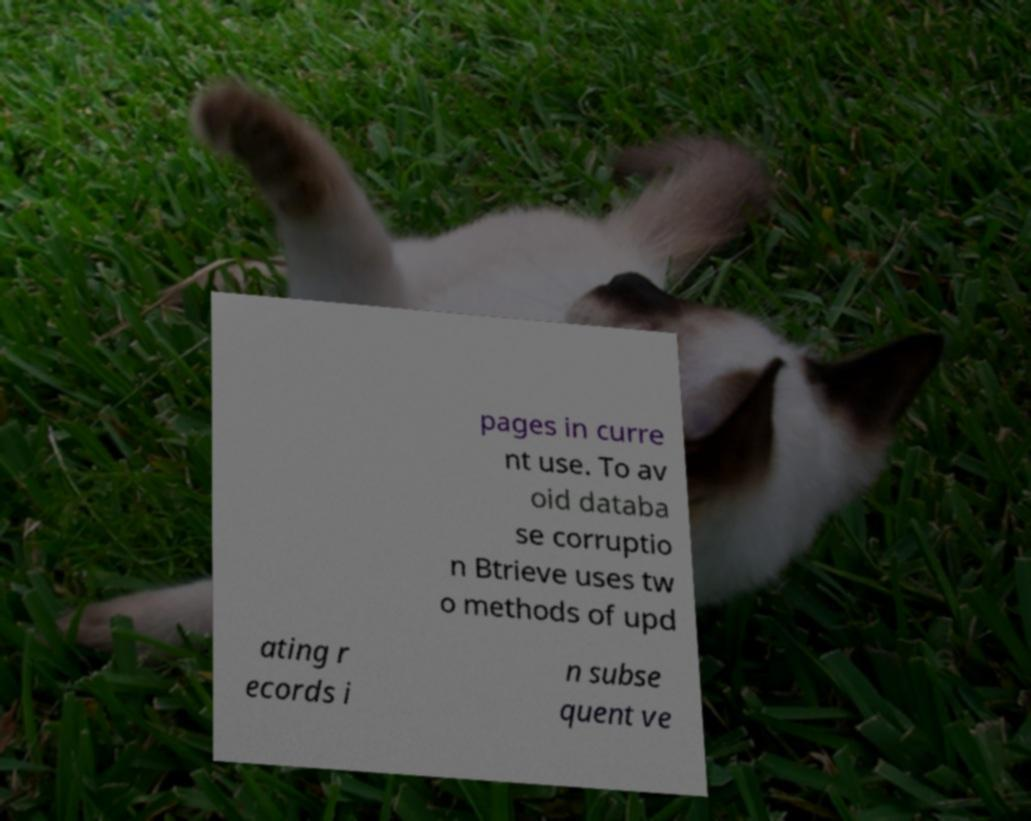Could you assist in decoding the text presented in this image and type it out clearly? pages in curre nt use. To av oid databa se corruptio n Btrieve uses tw o methods of upd ating r ecords i n subse quent ve 